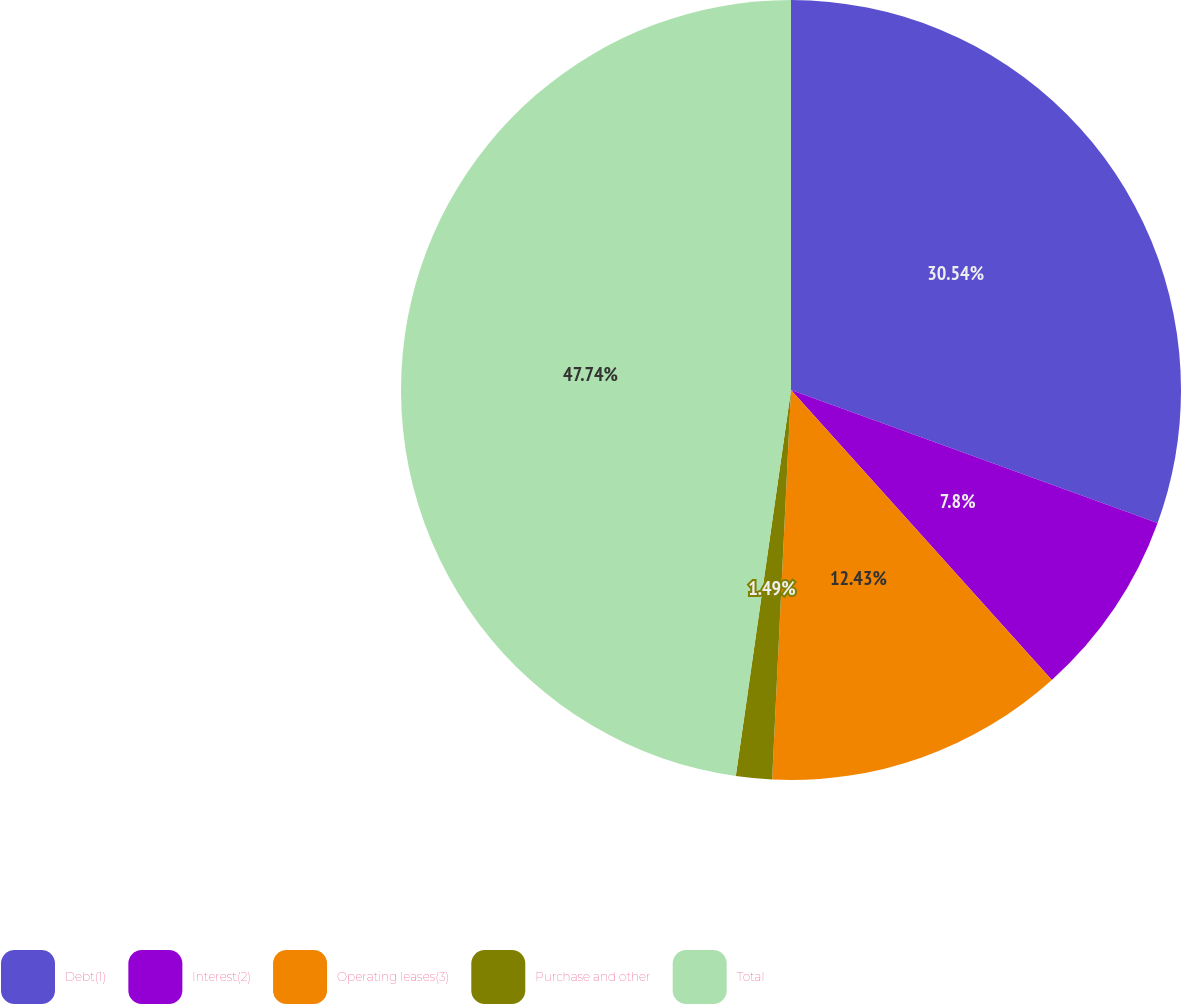<chart> <loc_0><loc_0><loc_500><loc_500><pie_chart><fcel>Debt(1)<fcel>Interest(2)<fcel>Operating leases(3)<fcel>Purchase and other<fcel>Total<nl><fcel>30.54%<fcel>7.8%<fcel>12.43%<fcel>1.49%<fcel>47.74%<nl></chart> 